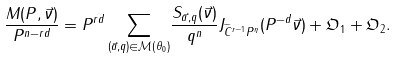Convert formula to latex. <formula><loc_0><loc_0><loc_500><loc_500>\frac { M ( P , \vec { \nu } ) } { P ^ { n - r d } } = P ^ { r d } \sum _ { ( \vec { a } , q ) \in \mathcal { M } ( \theta _ { 0 } ) } & \frac { S _ { \vec { a } , q } ( \vec { \nu } ) } { q ^ { n } } J _ { \widetilde { C } ^ { r - 1 } P ^ { \eta } } ( P ^ { - d } \vec { \nu } ) + \mathfrak { O } _ { 1 } + \mathfrak { O } _ { 2 } .</formula> 